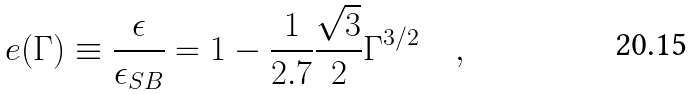Convert formula to latex. <formula><loc_0><loc_0><loc_500><loc_500>e ( \Gamma ) \equiv \frac { \epsilon } { \epsilon _ { S B } } = 1 - \frac { 1 } { 2 . 7 } \frac { \sqrt { 3 } } { 2 } \Gamma ^ { 3 / 2 } \quad ,</formula> 